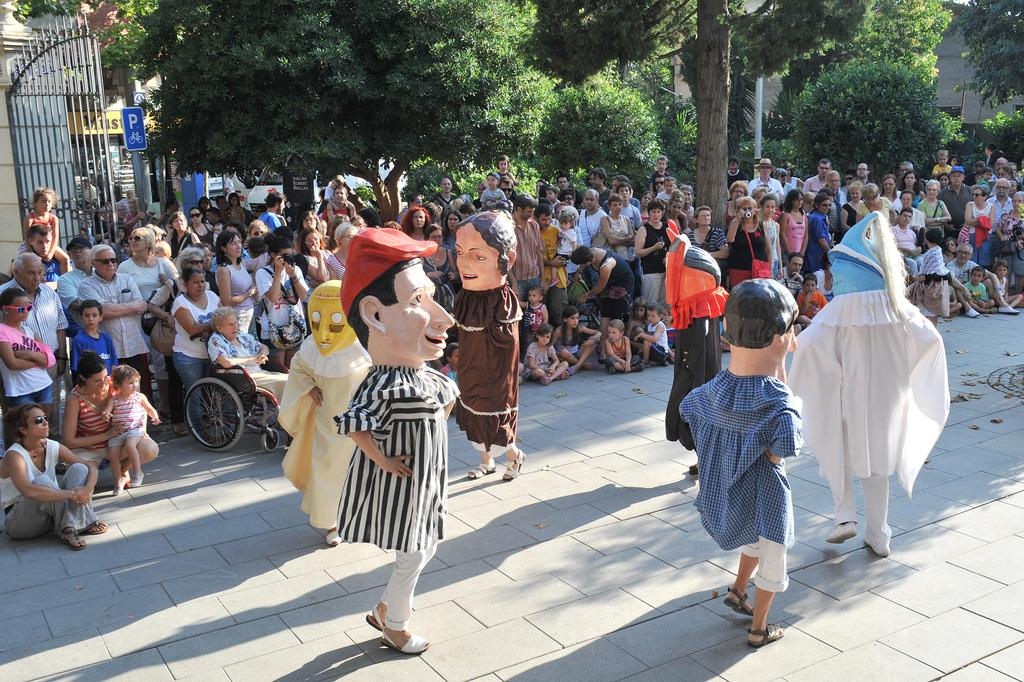What type of objects can be seen in the image? There are statues in the image. Are there any living beings in the image? Yes, there are people in the image. What type of mobility aid is present in the image? There is a wheelchair in the image. What architectural feature can be seen in the image? There is a gate in the image. What type of natural elements are present in the image? There are trees in the image. What type of man-made structures can be seen in the image? There are houses in the image. What type of representative is depicted in the image? There is no representative depicted in the image; it features statues, people, a wheelchair, a gate, trees, and houses. Can you tell me how many times the governor jumps in the image? There is no governor present in the image, and therefore no such activity can be observed. 